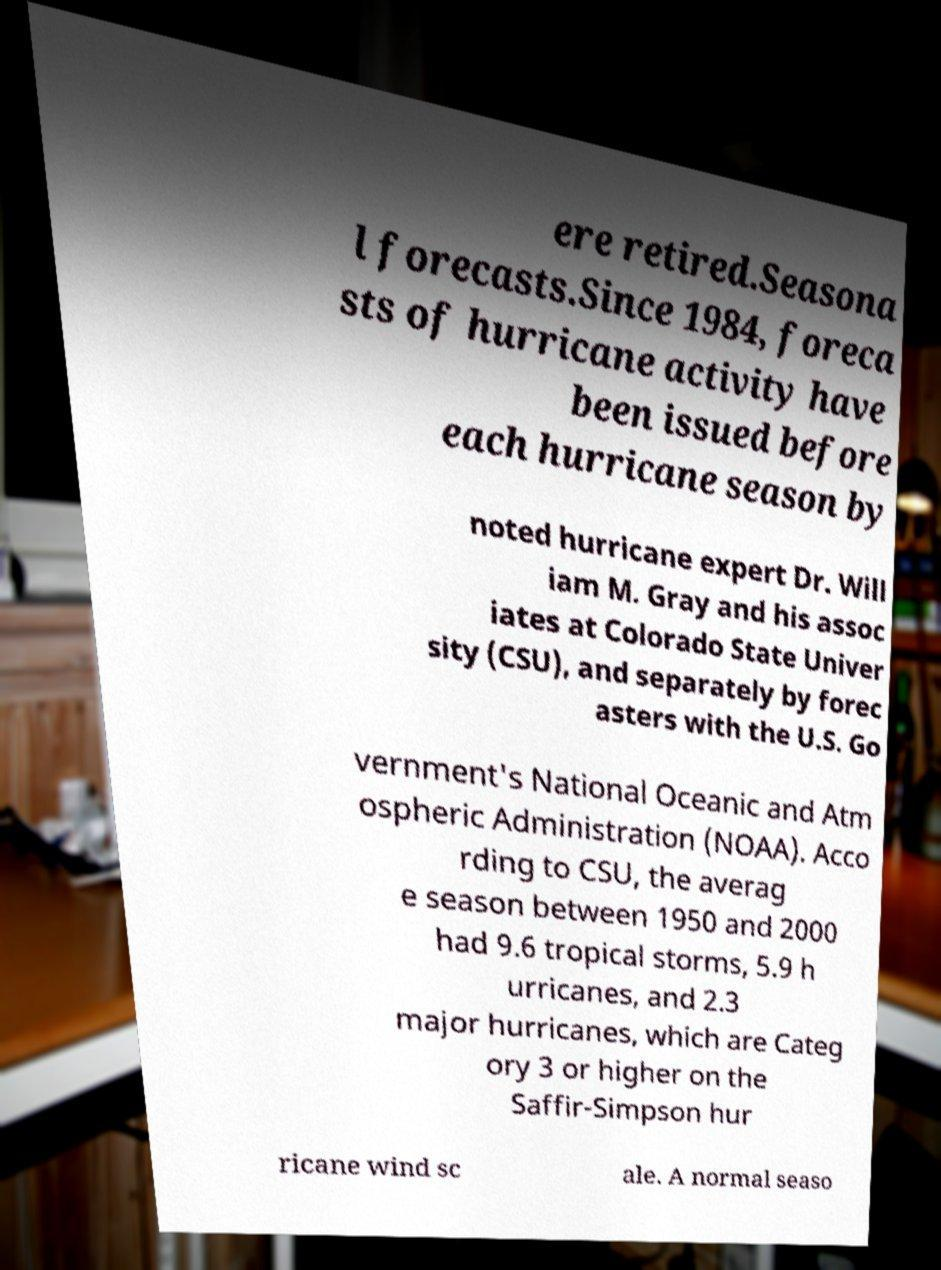Please identify and transcribe the text found in this image. ere retired.Seasona l forecasts.Since 1984, foreca sts of hurricane activity have been issued before each hurricane season by noted hurricane expert Dr. Will iam M. Gray and his assoc iates at Colorado State Univer sity (CSU), and separately by forec asters with the U.S. Go vernment's National Oceanic and Atm ospheric Administration (NOAA). Acco rding to CSU, the averag e season between 1950 and 2000 had 9.6 tropical storms, 5.9 h urricanes, and 2.3 major hurricanes, which are Categ ory 3 or higher on the Saffir-Simpson hur ricane wind sc ale. A normal seaso 